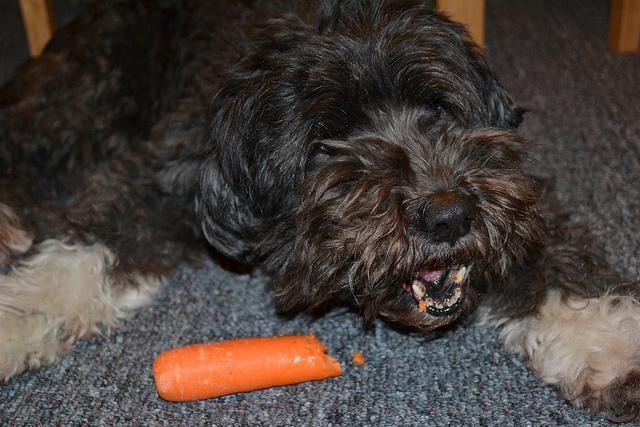How many dogs are there?
Give a very brief answer. 1. How many men are there?
Give a very brief answer. 0. 